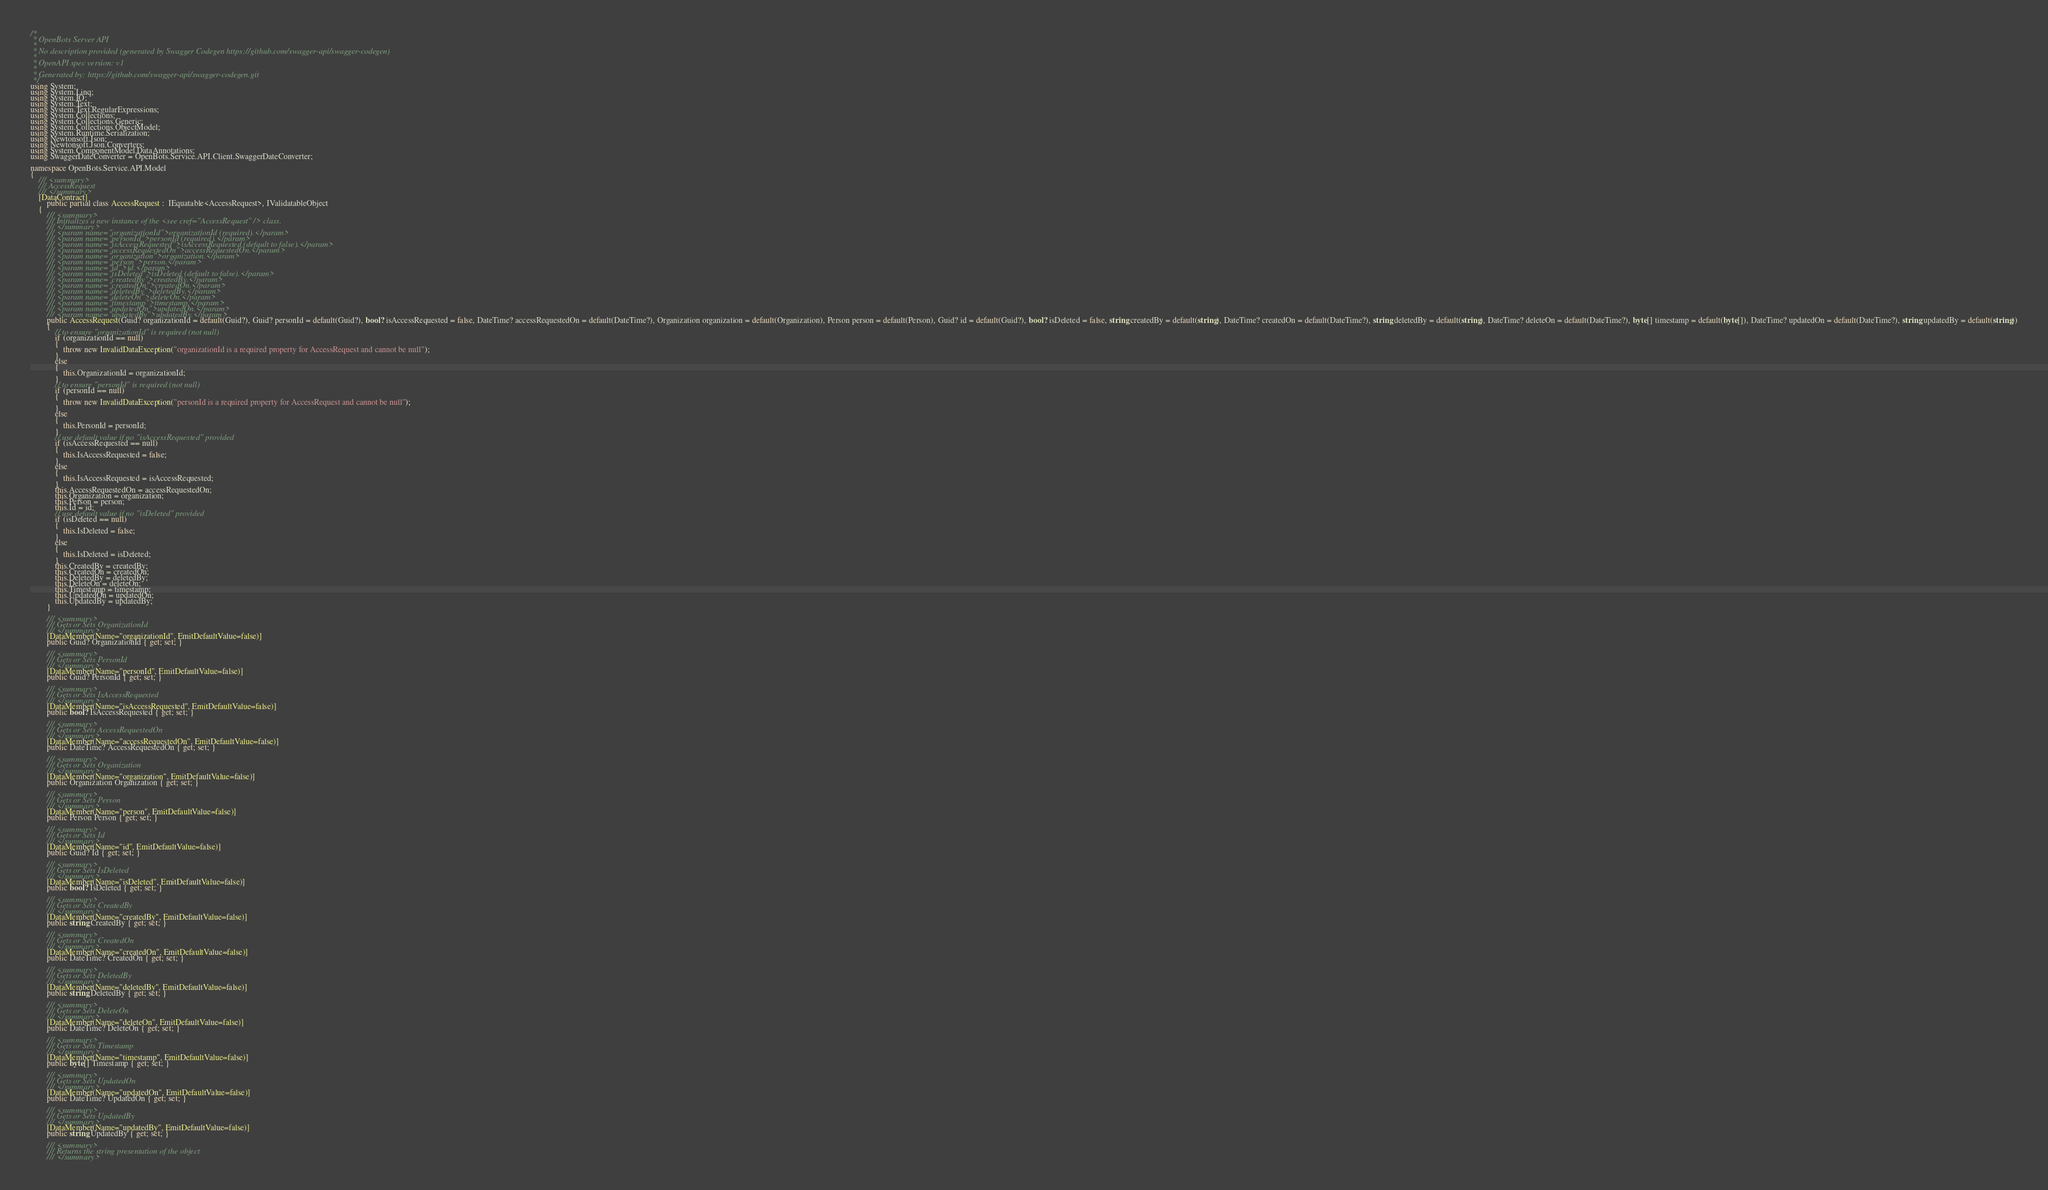<code> <loc_0><loc_0><loc_500><loc_500><_C#_>/* 
 * OpenBots Server API
 *
 * No description provided (generated by Swagger Codegen https://github.com/swagger-api/swagger-codegen)
 *
 * OpenAPI spec version: v1
 * 
 * Generated by: https://github.com/swagger-api/swagger-codegen.git
 */
using System;
using System.Linq;
using System.IO;
using System.Text;
using System.Text.RegularExpressions;
using System.Collections;
using System.Collections.Generic;
using System.Collections.ObjectModel;
using System.Runtime.Serialization;
using Newtonsoft.Json;
using Newtonsoft.Json.Converters;
using System.ComponentModel.DataAnnotations;
using SwaggerDateConverter = OpenBots.Service.API.Client.SwaggerDateConverter;

namespace OpenBots.Service.API.Model
{
    /// <summary>
    /// AccessRequest
    /// </summary>
    [DataContract]
        public partial class AccessRequest :  IEquatable<AccessRequest>, IValidatableObject
    {
        /// <summary>
        /// Initializes a new instance of the <see cref="AccessRequest" /> class.
        /// </summary>
        /// <param name="organizationId">organizationId (required).</param>
        /// <param name="personId">personId (required).</param>
        /// <param name="isAccessRequested">isAccessRequested (default to false).</param>
        /// <param name="accessRequestedOn">accessRequestedOn.</param>
        /// <param name="organization">organization.</param>
        /// <param name="person">person.</param>
        /// <param name="id">id.</param>
        /// <param name="isDeleted">isDeleted (default to false).</param>
        /// <param name="createdBy">createdBy.</param>
        /// <param name="createdOn">createdOn.</param>
        /// <param name="deletedBy">deletedBy.</param>
        /// <param name="deleteOn">deleteOn.</param>
        /// <param name="timestamp">timestamp.</param>
        /// <param name="updatedOn">updatedOn.</param>
        /// <param name="updatedBy">updatedBy.</param>
        public AccessRequest(Guid? organizationId = default(Guid?), Guid? personId = default(Guid?), bool? isAccessRequested = false, DateTime? accessRequestedOn = default(DateTime?), Organization organization = default(Organization), Person person = default(Person), Guid? id = default(Guid?), bool? isDeleted = false, string createdBy = default(string), DateTime? createdOn = default(DateTime?), string deletedBy = default(string), DateTime? deleteOn = default(DateTime?), byte[] timestamp = default(byte[]), DateTime? updatedOn = default(DateTime?), string updatedBy = default(string))
        {
            // to ensure "organizationId" is required (not null)
            if (organizationId == null)
            {
                throw new InvalidDataException("organizationId is a required property for AccessRequest and cannot be null");
            }
            else
            {
                this.OrganizationId = organizationId;
            }
            // to ensure "personId" is required (not null)
            if (personId == null)
            {
                throw new InvalidDataException("personId is a required property for AccessRequest and cannot be null");
            }
            else
            {
                this.PersonId = personId;
            }
            // use default value if no "isAccessRequested" provided
            if (isAccessRequested == null)
            {
                this.IsAccessRequested = false;
            }
            else
            {
                this.IsAccessRequested = isAccessRequested;
            }
            this.AccessRequestedOn = accessRequestedOn;
            this.Organization = organization;
            this.Person = person;
            this.Id = id;
            // use default value if no "isDeleted" provided
            if (isDeleted == null)
            {
                this.IsDeleted = false;
            }
            else
            {
                this.IsDeleted = isDeleted;
            }
            this.CreatedBy = createdBy;
            this.CreatedOn = createdOn;
            this.DeletedBy = deletedBy;
            this.DeleteOn = deleteOn;
            this.Timestamp = timestamp;
            this.UpdatedOn = updatedOn;
            this.UpdatedBy = updatedBy;
        }
        
        /// <summary>
        /// Gets or Sets OrganizationId
        /// </summary>
        [DataMember(Name="organizationId", EmitDefaultValue=false)]
        public Guid? OrganizationId { get; set; }

        /// <summary>
        /// Gets or Sets PersonId
        /// </summary>
        [DataMember(Name="personId", EmitDefaultValue=false)]
        public Guid? PersonId { get; set; }

        /// <summary>
        /// Gets or Sets IsAccessRequested
        /// </summary>
        [DataMember(Name="isAccessRequested", EmitDefaultValue=false)]
        public bool? IsAccessRequested { get; set; }

        /// <summary>
        /// Gets or Sets AccessRequestedOn
        /// </summary>
        [DataMember(Name="accessRequestedOn", EmitDefaultValue=false)]
        public DateTime? AccessRequestedOn { get; set; }

        /// <summary>
        /// Gets or Sets Organization
        /// </summary>
        [DataMember(Name="organization", EmitDefaultValue=false)]
        public Organization Organization { get; set; }

        /// <summary>
        /// Gets or Sets Person
        /// </summary>
        [DataMember(Name="person", EmitDefaultValue=false)]
        public Person Person { get; set; }

        /// <summary>
        /// Gets or Sets Id
        /// </summary>
        [DataMember(Name="id", EmitDefaultValue=false)]
        public Guid? Id { get; set; }

        /// <summary>
        /// Gets or Sets IsDeleted
        /// </summary>
        [DataMember(Name="isDeleted", EmitDefaultValue=false)]
        public bool? IsDeleted { get; set; }

        /// <summary>
        /// Gets or Sets CreatedBy
        /// </summary>
        [DataMember(Name="createdBy", EmitDefaultValue=false)]
        public string CreatedBy { get; set; }

        /// <summary>
        /// Gets or Sets CreatedOn
        /// </summary>
        [DataMember(Name="createdOn", EmitDefaultValue=false)]
        public DateTime? CreatedOn { get; set; }

        /// <summary>
        /// Gets or Sets DeletedBy
        /// </summary>
        [DataMember(Name="deletedBy", EmitDefaultValue=false)]
        public string DeletedBy { get; set; }

        /// <summary>
        /// Gets or Sets DeleteOn
        /// </summary>
        [DataMember(Name="deleteOn", EmitDefaultValue=false)]
        public DateTime? DeleteOn { get; set; }

        /// <summary>
        /// Gets or Sets Timestamp
        /// </summary>
        [DataMember(Name="timestamp", EmitDefaultValue=false)]
        public byte[] Timestamp { get; set; }

        /// <summary>
        /// Gets or Sets UpdatedOn
        /// </summary>
        [DataMember(Name="updatedOn", EmitDefaultValue=false)]
        public DateTime? UpdatedOn { get; set; }

        /// <summary>
        /// Gets or Sets UpdatedBy
        /// </summary>
        [DataMember(Name="updatedBy", EmitDefaultValue=false)]
        public string UpdatedBy { get; set; }

        /// <summary>
        /// Returns the string presentation of the object
        /// </summary></code> 